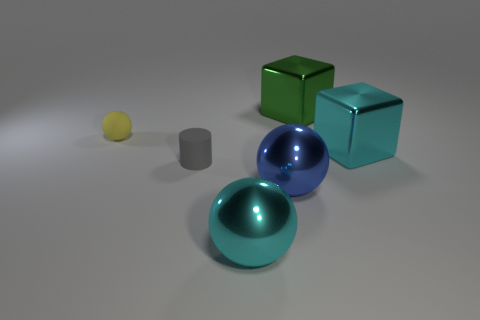Is the number of gray matte cylinders that are to the right of the large blue shiny object the same as the number of big brown matte blocks?
Your response must be concise. Yes. How many things are either large cyan metal spheres or big cubes that are behind the big blue object?
Keep it short and to the point. 3. Is there a green cylinder that has the same material as the big green object?
Give a very brief answer. No. The other shiny object that is the same shape as the green metal thing is what color?
Keep it short and to the point. Cyan. Are the green object and the tiny thing to the left of the small gray rubber object made of the same material?
Give a very brief answer. No. The matte thing on the right side of the tiny yellow ball that is behind the blue metal sphere is what shape?
Provide a short and direct response. Cylinder. There is a cyan thing that is to the left of the green cube; is its size the same as the tiny matte cylinder?
Offer a terse response. No. What number of other things are the same shape as the gray matte thing?
Provide a short and direct response. 0. What number of green objects are behind the big blue object?
Your answer should be compact. 1. What number of other objects are there of the same size as the green metal thing?
Your response must be concise. 3. 